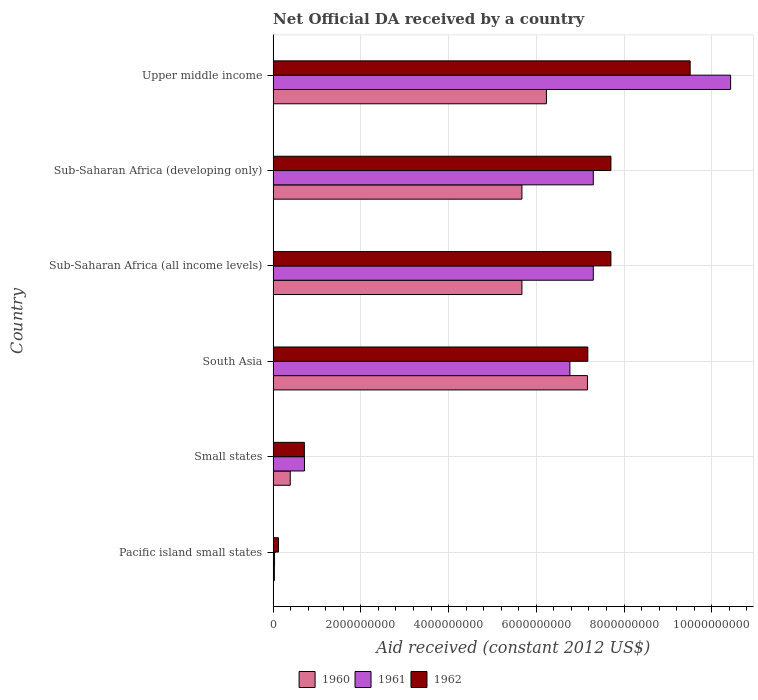How many different coloured bars are there?
Your response must be concise. 3. Are the number of bars on each tick of the Y-axis equal?
Ensure brevity in your answer.  Yes. How many bars are there on the 2nd tick from the top?
Provide a short and direct response. 3. How many bars are there on the 4th tick from the bottom?
Your answer should be compact. 3. What is the label of the 3rd group of bars from the top?
Offer a terse response. Sub-Saharan Africa (all income levels). What is the net official development assistance aid received in 1961 in South Asia?
Your answer should be compact. 6.76e+09. Across all countries, what is the maximum net official development assistance aid received in 1962?
Your answer should be compact. 9.51e+09. Across all countries, what is the minimum net official development assistance aid received in 1961?
Give a very brief answer. 3.25e+07. In which country was the net official development assistance aid received in 1962 maximum?
Provide a succinct answer. Upper middle income. In which country was the net official development assistance aid received in 1960 minimum?
Offer a terse response. Pacific island small states. What is the total net official development assistance aid received in 1960 in the graph?
Your response must be concise. 2.52e+1. What is the difference between the net official development assistance aid received in 1961 in South Asia and that in Upper middle income?
Keep it short and to the point. -3.66e+09. What is the difference between the net official development assistance aid received in 1962 in Upper middle income and the net official development assistance aid received in 1960 in Sub-Saharan Africa (developing only)?
Provide a succinct answer. 3.83e+09. What is the average net official development assistance aid received in 1961 per country?
Keep it short and to the point. 5.42e+09. What is the difference between the net official development assistance aid received in 1961 and net official development assistance aid received in 1960 in South Asia?
Your response must be concise. -4.00e+08. In how many countries, is the net official development assistance aid received in 1961 greater than 2800000000 US$?
Offer a terse response. 4. What is the ratio of the net official development assistance aid received in 1961 in Pacific island small states to that in Small states?
Provide a succinct answer. 0.05. Is the net official development assistance aid received in 1960 in Pacific island small states less than that in Small states?
Provide a short and direct response. Yes. What is the difference between the highest and the second highest net official development assistance aid received in 1960?
Provide a short and direct response. 9.35e+08. What is the difference between the highest and the lowest net official development assistance aid received in 1961?
Ensure brevity in your answer.  1.04e+1. In how many countries, is the net official development assistance aid received in 1962 greater than the average net official development assistance aid received in 1962 taken over all countries?
Your response must be concise. 4. Is the sum of the net official development assistance aid received in 1961 in Pacific island small states and South Asia greater than the maximum net official development assistance aid received in 1962 across all countries?
Offer a terse response. No. What does the 2nd bar from the bottom in Sub-Saharan Africa (all income levels) represents?
Offer a very short reply. 1961. Is it the case that in every country, the sum of the net official development assistance aid received in 1960 and net official development assistance aid received in 1962 is greater than the net official development assistance aid received in 1961?
Provide a succinct answer. Yes. How many bars are there?
Offer a very short reply. 18. How many countries are there in the graph?
Provide a short and direct response. 6. Does the graph contain grids?
Offer a very short reply. Yes. Where does the legend appear in the graph?
Keep it short and to the point. Bottom center. How are the legend labels stacked?
Offer a terse response. Horizontal. What is the title of the graph?
Ensure brevity in your answer.  Net Official DA received by a country. Does "1960" appear as one of the legend labels in the graph?
Your answer should be very brief. Yes. What is the label or title of the X-axis?
Offer a terse response. Aid received (constant 2012 US$). What is the Aid received (constant 2012 US$) in 1960 in Pacific island small states?
Offer a very short reply. 2.87e+07. What is the Aid received (constant 2012 US$) in 1961 in Pacific island small states?
Your answer should be very brief. 3.25e+07. What is the Aid received (constant 2012 US$) in 1962 in Pacific island small states?
Provide a succinct answer. 1.22e+08. What is the Aid received (constant 2012 US$) of 1960 in Small states?
Provide a short and direct response. 3.90e+08. What is the Aid received (constant 2012 US$) of 1961 in Small states?
Make the answer very short. 7.15e+08. What is the Aid received (constant 2012 US$) of 1962 in Small states?
Your response must be concise. 7.12e+08. What is the Aid received (constant 2012 US$) of 1960 in South Asia?
Your answer should be compact. 7.17e+09. What is the Aid received (constant 2012 US$) in 1961 in South Asia?
Your answer should be very brief. 6.76e+09. What is the Aid received (constant 2012 US$) in 1962 in South Asia?
Make the answer very short. 7.17e+09. What is the Aid received (constant 2012 US$) in 1960 in Sub-Saharan Africa (all income levels)?
Offer a very short reply. 5.67e+09. What is the Aid received (constant 2012 US$) in 1961 in Sub-Saharan Africa (all income levels)?
Provide a short and direct response. 7.30e+09. What is the Aid received (constant 2012 US$) of 1962 in Sub-Saharan Africa (all income levels)?
Provide a short and direct response. 7.70e+09. What is the Aid received (constant 2012 US$) in 1960 in Sub-Saharan Africa (developing only)?
Make the answer very short. 5.67e+09. What is the Aid received (constant 2012 US$) of 1961 in Sub-Saharan Africa (developing only)?
Keep it short and to the point. 7.30e+09. What is the Aid received (constant 2012 US$) in 1962 in Sub-Saharan Africa (developing only)?
Your answer should be very brief. 7.70e+09. What is the Aid received (constant 2012 US$) in 1960 in Upper middle income?
Ensure brevity in your answer.  6.23e+09. What is the Aid received (constant 2012 US$) of 1961 in Upper middle income?
Provide a succinct answer. 1.04e+1. What is the Aid received (constant 2012 US$) of 1962 in Upper middle income?
Your answer should be very brief. 9.51e+09. Across all countries, what is the maximum Aid received (constant 2012 US$) of 1960?
Your response must be concise. 7.17e+09. Across all countries, what is the maximum Aid received (constant 2012 US$) in 1961?
Provide a short and direct response. 1.04e+1. Across all countries, what is the maximum Aid received (constant 2012 US$) in 1962?
Provide a succinct answer. 9.51e+09. Across all countries, what is the minimum Aid received (constant 2012 US$) of 1960?
Ensure brevity in your answer.  2.87e+07. Across all countries, what is the minimum Aid received (constant 2012 US$) in 1961?
Make the answer very short. 3.25e+07. Across all countries, what is the minimum Aid received (constant 2012 US$) in 1962?
Provide a succinct answer. 1.22e+08. What is the total Aid received (constant 2012 US$) in 1960 in the graph?
Ensure brevity in your answer.  2.52e+1. What is the total Aid received (constant 2012 US$) of 1961 in the graph?
Provide a succinct answer. 3.25e+1. What is the total Aid received (constant 2012 US$) of 1962 in the graph?
Provide a short and direct response. 3.29e+1. What is the difference between the Aid received (constant 2012 US$) of 1960 in Pacific island small states and that in Small states?
Offer a very short reply. -3.62e+08. What is the difference between the Aid received (constant 2012 US$) of 1961 in Pacific island small states and that in Small states?
Provide a short and direct response. -6.82e+08. What is the difference between the Aid received (constant 2012 US$) of 1962 in Pacific island small states and that in Small states?
Your answer should be very brief. -5.90e+08. What is the difference between the Aid received (constant 2012 US$) in 1960 in Pacific island small states and that in South Asia?
Your response must be concise. -7.14e+09. What is the difference between the Aid received (constant 2012 US$) in 1961 in Pacific island small states and that in South Asia?
Make the answer very short. -6.73e+09. What is the difference between the Aid received (constant 2012 US$) of 1962 in Pacific island small states and that in South Asia?
Provide a succinct answer. -7.05e+09. What is the difference between the Aid received (constant 2012 US$) in 1960 in Pacific island small states and that in Sub-Saharan Africa (all income levels)?
Your response must be concise. -5.64e+09. What is the difference between the Aid received (constant 2012 US$) in 1961 in Pacific island small states and that in Sub-Saharan Africa (all income levels)?
Offer a very short reply. -7.27e+09. What is the difference between the Aid received (constant 2012 US$) in 1962 in Pacific island small states and that in Sub-Saharan Africa (all income levels)?
Your answer should be compact. -7.58e+09. What is the difference between the Aid received (constant 2012 US$) of 1960 in Pacific island small states and that in Sub-Saharan Africa (developing only)?
Offer a very short reply. -5.64e+09. What is the difference between the Aid received (constant 2012 US$) of 1961 in Pacific island small states and that in Sub-Saharan Africa (developing only)?
Provide a short and direct response. -7.27e+09. What is the difference between the Aid received (constant 2012 US$) of 1962 in Pacific island small states and that in Sub-Saharan Africa (developing only)?
Offer a very short reply. -7.58e+09. What is the difference between the Aid received (constant 2012 US$) in 1960 in Pacific island small states and that in Upper middle income?
Your response must be concise. -6.20e+09. What is the difference between the Aid received (constant 2012 US$) of 1961 in Pacific island small states and that in Upper middle income?
Provide a short and direct response. -1.04e+1. What is the difference between the Aid received (constant 2012 US$) in 1962 in Pacific island small states and that in Upper middle income?
Your response must be concise. -9.38e+09. What is the difference between the Aid received (constant 2012 US$) in 1960 in Small states and that in South Asia?
Make the answer very short. -6.77e+09. What is the difference between the Aid received (constant 2012 US$) in 1961 in Small states and that in South Asia?
Offer a terse response. -6.05e+09. What is the difference between the Aid received (constant 2012 US$) in 1962 in Small states and that in South Asia?
Provide a short and direct response. -6.46e+09. What is the difference between the Aid received (constant 2012 US$) in 1960 in Small states and that in Sub-Saharan Africa (all income levels)?
Provide a short and direct response. -5.28e+09. What is the difference between the Aid received (constant 2012 US$) in 1961 in Small states and that in Sub-Saharan Africa (all income levels)?
Keep it short and to the point. -6.58e+09. What is the difference between the Aid received (constant 2012 US$) in 1962 in Small states and that in Sub-Saharan Africa (all income levels)?
Your response must be concise. -6.99e+09. What is the difference between the Aid received (constant 2012 US$) of 1960 in Small states and that in Sub-Saharan Africa (developing only)?
Provide a succinct answer. -5.28e+09. What is the difference between the Aid received (constant 2012 US$) of 1961 in Small states and that in Sub-Saharan Africa (developing only)?
Keep it short and to the point. -6.58e+09. What is the difference between the Aid received (constant 2012 US$) in 1962 in Small states and that in Sub-Saharan Africa (developing only)?
Keep it short and to the point. -6.99e+09. What is the difference between the Aid received (constant 2012 US$) of 1960 in Small states and that in Upper middle income?
Offer a terse response. -5.84e+09. What is the difference between the Aid received (constant 2012 US$) in 1961 in Small states and that in Upper middle income?
Give a very brief answer. -9.71e+09. What is the difference between the Aid received (constant 2012 US$) in 1962 in Small states and that in Upper middle income?
Give a very brief answer. -8.79e+09. What is the difference between the Aid received (constant 2012 US$) of 1960 in South Asia and that in Sub-Saharan Africa (all income levels)?
Provide a succinct answer. 1.49e+09. What is the difference between the Aid received (constant 2012 US$) of 1961 in South Asia and that in Sub-Saharan Africa (all income levels)?
Your answer should be compact. -5.34e+08. What is the difference between the Aid received (constant 2012 US$) of 1962 in South Asia and that in Sub-Saharan Africa (all income levels)?
Give a very brief answer. -5.27e+08. What is the difference between the Aid received (constant 2012 US$) in 1960 in South Asia and that in Sub-Saharan Africa (developing only)?
Make the answer very short. 1.49e+09. What is the difference between the Aid received (constant 2012 US$) in 1961 in South Asia and that in Sub-Saharan Africa (developing only)?
Give a very brief answer. -5.34e+08. What is the difference between the Aid received (constant 2012 US$) of 1962 in South Asia and that in Sub-Saharan Africa (developing only)?
Offer a terse response. -5.27e+08. What is the difference between the Aid received (constant 2012 US$) in 1960 in South Asia and that in Upper middle income?
Your answer should be very brief. 9.35e+08. What is the difference between the Aid received (constant 2012 US$) in 1961 in South Asia and that in Upper middle income?
Offer a very short reply. -3.66e+09. What is the difference between the Aid received (constant 2012 US$) in 1962 in South Asia and that in Upper middle income?
Provide a succinct answer. -2.33e+09. What is the difference between the Aid received (constant 2012 US$) in 1961 in Sub-Saharan Africa (all income levels) and that in Sub-Saharan Africa (developing only)?
Provide a short and direct response. 0. What is the difference between the Aid received (constant 2012 US$) of 1960 in Sub-Saharan Africa (all income levels) and that in Upper middle income?
Your answer should be very brief. -5.58e+08. What is the difference between the Aid received (constant 2012 US$) in 1961 in Sub-Saharan Africa (all income levels) and that in Upper middle income?
Make the answer very short. -3.13e+09. What is the difference between the Aid received (constant 2012 US$) of 1962 in Sub-Saharan Africa (all income levels) and that in Upper middle income?
Provide a short and direct response. -1.81e+09. What is the difference between the Aid received (constant 2012 US$) of 1960 in Sub-Saharan Africa (developing only) and that in Upper middle income?
Keep it short and to the point. -5.58e+08. What is the difference between the Aid received (constant 2012 US$) of 1961 in Sub-Saharan Africa (developing only) and that in Upper middle income?
Ensure brevity in your answer.  -3.13e+09. What is the difference between the Aid received (constant 2012 US$) of 1962 in Sub-Saharan Africa (developing only) and that in Upper middle income?
Your response must be concise. -1.81e+09. What is the difference between the Aid received (constant 2012 US$) in 1960 in Pacific island small states and the Aid received (constant 2012 US$) in 1961 in Small states?
Make the answer very short. -6.86e+08. What is the difference between the Aid received (constant 2012 US$) of 1960 in Pacific island small states and the Aid received (constant 2012 US$) of 1962 in Small states?
Give a very brief answer. -6.83e+08. What is the difference between the Aid received (constant 2012 US$) of 1961 in Pacific island small states and the Aid received (constant 2012 US$) of 1962 in Small states?
Offer a very short reply. -6.80e+08. What is the difference between the Aid received (constant 2012 US$) in 1960 in Pacific island small states and the Aid received (constant 2012 US$) in 1961 in South Asia?
Keep it short and to the point. -6.74e+09. What is the difference between the Aid received (constant 2012 US$) of 1960 in Pacific island small states and the Aid received (constant 2012 US$) of 1962 in South Asia?
Your response must be concise. -7.14e+09. What is the difference between the Aid received (constant 2012 US$) in 1961 in Pacific island small states and the Aid received (constant 2012 US$) in 1962 in South Asia?
Offer a terse response. -7.14e+09. What is the difference between the Aid received (constant 2012 US$) in 1960 in Pacific island small states and the Aid received (constant 2012 US$) in 1961 in Sub-Saharan Africa (all income levels)?
Offer a very short reply. -7.27e+09. What is the difference between the Aid received (constant 2012 US$) in 1960 in Pacific island small states and the Aid received (constant 2012 US$) in 1962 in Sub-Saharan Africa (all income levels)?
Your response must be concise. -7.67e+09. What is the difference between the Aid received (constant 2012 US$) of 1961 in Pacific island small states and the Aid received (constant 2012 US$) of 1962 in Sub-Saharan Africa (all income levels)?
Offer a terse response. -7.67e+09. What is the difference between the Aid received (constant 2012 US$) of 1960 in Pacific island small states and the Aid received (constant 2012 US$) of 1961 in Sub-Saharan Africa (developing only)?
Make the answer very short. -7.27e+09. What is the difference between the Aid received (constant 2012 US$) in 1960 in Pacific island small states and the Aid received (constant 2012 US$) in 1962 in Sub-Saharan Africa (developing only)?
Your answer should be very brief. -7.67e+09. What is the difference between the Aid received (constant 2012 US$) in 1961 in Pacific island small states and the Aid received (constant 2012 US$) in 1962 in Sub-Saharan Africa (developing only)?
Give a very brief answer. -7.67e+09. What is the difference between the Aid received (constant 2012 US$) in 1960 in Pacific island small states and the Aid received (constant 2012 US$) in 1961 in Upper middle income?
Keep it short and to the point. -1.04e+1. What is the difference between the Aid received (constant 2012 US$) of 1960 in Pacific island small states and the Aid received (constant 2012 US$) of 1962 in Upper middle income?
Offer a terse response. -9.48e+09. What is the difference between the Aid received (constant 2012 US$) in 1961 in Pacific island small states and the Aid received (constant 2012 US$) in 1962 in Upper middle income?
Offer a terse response. -9.47e+09. What is the difference between the Aid received (constant 2012 US$) of 1960 in Small states and the Aid received (constant 2012 US$) of 1961 in South Asia?
Provide a short and direct response. -6.37e+09. What is the difference between the Aid received (constant 2012 US$) of 1960 in Small states and the Aid received (constant 2012 US$) of 1962 in South Asia?
Your answer should be very brief. -6.78e+09. What is the difference between the Aid received (constant 2012 US$) of 1961 in Small states and the Aid received (constant 2012 US$) of 1962 in South Asia?
Your response must be concise. -6.46e+09. What is the difference between the Aid received (constant 2012 US$) of 1960 in Small states and the Aid received (constant 2012 US$) of 1961 in Sub-Saharan Africa (all income levels)?
Provide a short and direct response. -6.91e+09. What is the difference between the Aid received (constant 2012 US$) of 1960 in Small states and the Aid received (constant 2012 US$) of 1962 in Sub-Saharan Africa (all income levels)?
Offer a very short reply. -7.31e+09. What is the difference between the Aid received (constant 2012 US$) of 1961 in Small states and the Aid received (constant 2012 US$) of 1962 in Sub-Saharan Africa (all income levels)?
Your answer should be compact. -6.99e+09. What is the difference between the Aid received (constant 2012 US$) in 1960 in Small states and the Aid received (constant 2012 US$) in 1961 in Sub-Saharan Africa (developing only)?
Offer a very short reply. -6.91e+09. What is the difference between the Aid received (constant 2012 US$) in 1960 in Small states and the Aid received (constant 2012 US$) in 1962 in Sub-Saharan Africa (developing only)?
Your response must be concise. -7.31e+09. What is the difference between the Aid received (constant 2012 US$) of 1961 in Small states and the Aid received (constant 2012 US$) of 1962 in Sub-Saharan Africa (developing only)?
Make the answer very short. -6.99e+09. What is the difference between the Aid received (constant 2012 US$) in 1960 in Small states and the Aid received (constant 2012 US$) in 1961 in Upper middle income?
Your answer should be very brief. -1.00e+1. What is the difference between the Aid received (constant 2012 US$) in 1960 in Small states and the Aid received (constant 2012 US$) in 1962 in Upper middle income?
Your answer should be very brief. -9.12e+09. What is the difference between the Aid received (constant 2012 US$) of 1961 in Small states and the Aid received (constant 2012 US$) of 1962 in Upper middle income?
Offer a very short reply. -8.79e+09. What is the difference between the Aid received (constant 2012 US$) of 1960 in South Asia and the Aid received (constant 2012 US$) of 1961 in Sub-Saharan Africa (all income levels)?
Offer a very short reply. -1.33e+08. What is the difference between the Aid received (constant 2012 US$) of 1960 in South Asia and the Aid received (constant 2012 US$) of 1962 in Sub-Saharan Africa (all income levels)?
Offer a terse response. -5.35e+08. What is the difference between the Aid received (constant 2012 US$) in 1961 in South Asia and the Aid received (constant 2012 US$) in 1962 in Sub-Saharan Africa (all income levels)?
Your answer should be compact. -9.35e+08. What is the difference between the Aid received (constant 2012 US$) of 1960 in South Asia and the Aid received (constant 2012 US$) of 1961 in Sub-Saharan Africa (developing only)?
Ensure brevity in your answer.  -1.33e+08. What is the difference between the Aid received (constant 2012 US$) in 1960 in South Asia and the Aid received (constant 2012 US$) in 1962 in Sub-Saharan Africa (developing only)?
Make the answer very short. -5.35e+08. What is the difference between the Aid received (constant 2012 US$) of 1961 in South Asia and the Aid received (constant 2012 US$) of 1962 in Sub-Saharan Africa (developing only)?
Your answer should be very brief. -9.35e+08. What is the difference between the Aid received (constant 2012 US$) of 1960 in South Asia and the Aid received (constant 2012 US$) of 1961 in Upper middle income?
Make the answer very short. -3.26e+09. What is the difference between the Aid received (constant 2012 US$) of 1960 in South Asia and the Aid received (constant 2012 US$) of 1962 in Upper middle income?
Make the answer very short. -2.34e+09. What is the difference between the Aid received (constant 2012 US$) of 1961 in South Asia and the Aid received (constant 2012 US$) of 1962 in Upper middle income?
Give a very brief answer. -2.74e+09. What is the difference between the Aid received (constant 2012 US$) of 1960 in Sub-Saharan Africa (all income levels) and the Aid received (constant 2012 US$) of 1961 in Sub-Saharan Africa (developing only)?
Provide a short and direct response. -1.63e+09. What is the difference between the Aid received (constant 2012 US$) in 1960 in Sub-Saharan Africa (all income levels) and the Aid received (constant 2012 US$) in 1962 in Sub-Saharan Africa (developing only)?
Make the answer very short. -2.03e+09. What is the difference between the Aid received (constant 2012 US$) in 1961 in Sub-Saharan Africa (all income levels) and the Aid received (constant 2012 US$) in 1962 in Sub-Saharan Africa (developing only)?
Keep it short and to the point. -4.02e+08. What is the difference between the Aid received (constant 2012 US$) in 1960 in Sub-Saharan Africa (all income levels) and the Aid received (constant 2012 US$) in 1961 in Upper middle income?
Provide a succinct answer. -4.76e+09. What is the difference between the Aid received (constant 2012 US$) of 1960 in Sub-Saharan Africa (all income levels) and the Aid received (constant 2012 US$) of 1962 in Upper middle income?
Your response must be concise. -3.83e+09. What is the difference between the Aid received (constant 2012 US$) of 1961 in Sub-Saharan Africa (all income levels) and the Aid received (constant 2012 US$) of 1962 in Upper middle income?
Provide a succinct answer. -2.21e+09. What is the difference between the Aid received (constant 2012 US$) in 1960 in Sub-Saharan Africa (developing only) and the Aid received (constant 2012 US$) in 1961 in Upper middle income?
Your response must be concise. -4.76e+09. What is the difference between the Aid received (constant 2012 US$) of 1960 in Sub-Saharan Africa (developing only) and the Aid received (constant 2012 US$) of 1962 in Upper middle income?
Ensure brevity in your answer.  -3.83e+09. What is the difference between the Aid received (constant 2012 US$) in 1961 in Sub-Saharan Africa (developing only) and the Aid received (constant 2012 US$) in 1962 in Upper middle income?
Your answer should be compact. -2.21e+09. What is the average Aid received (constant 2012 US$) of 1960 per country?
Your answer should be very brief. 4.19e+09. What is the average Aid received (constant 2012 US$) in 1961 per country?
Your answer should be compact. 5.42e+09. What is the average Aid received (constant 2012 US$) of 1962 per country?
Ensure brevity in your answer.  5.49e+09. What is the difference between the Aid received (constant 2012 US$) of 1960 and Aid received (constant 2012 US$) of 1961 in Pacific island small states?
Keep it short and to the point. -3.76e+06. What is the difference between the Aid received (constant 2012 US$) of 1960 and Aid received (constant 2012 US$) of 1962 in Pacific island small states?
Keep it short and to the point. -9.36e+07. What is the difference between the Aid received (constant 2012 US$) of 1961 and Aid received (constant 2012 US$) of 1962 in Pacific island small states?
Make the answer very short. -8.98e+07. What is the difference between the Aid received (constant 2012 US$) in 1960 and Aid received (constant 2012 US$) in 1961 in Small states?
Your response must be concise. -3.24e+08. What is the difference between the Aid received (constant 2012 US$) of 1960 and Aid received (constant 2012 US$) of 1962 in Small states?
Offer a very short reply. -3.22e+08. What is the difference between the Aid received (constant 2012 US$) in 1961 and Aid received (constant 2012 US$) in 1962 in Small states?
Make the answer very short. 2.71e+06. What is the difference between the Aid received (constant 2012 US$) of 1960 and Aid received (constant 2012 US$) of 1961 in South Asia?
Offer a very short reply. 4.00e+08. What is the difference between the Aid received (constant 2012 US$) in 1960 and Aid received (constant 2012 US$) in 1962 in South Asia?
Your answer should be compact. -8.03e+06. What is the difference between the Aid received (constant 2012 US$) in 1961 and Aid received (constant 2012 US$) in 1962 in South Asia?
Make the answer very short. -4.08e+08. What is the difference between the Aid received (constant 2012 US$) of 1960 and Aid received (constant 2012 US$) of 1961 in Sub-Saharan Africa (all income levels)?
Ensure brevity in your answer.  -1.63e+09. What is the difference between the Aid received (constant 2012 US$) in 1960 and Aid received (constant 2012 US$) in 1962 in Sub-Saharan Africa (all income levels)?
Keep it short and to the point. -2.03e+09. What is the difference between the Aid received (constant 2012 US$) of 1961 and Aid received (constant 2012 US$) of 1962 in Sub-Saharan Africa (all income levels)?
Give a very brief answer. -4.02e+08. What is the difference between the Aid received (constant 2012 US$) in 1960 and Aid received (constant 2012 US$) in 1961 in Sub-Saharan Africa (developing only)?
Make the answer very short. -1.63e+09. What is the difference between the Aid received (constant 2012 US$) in 1960 and Aid received (constant 2012 US$) in 1962 in Sub-Saharan Africa (developing only)?
Keep it short and to the point. -2.03e+09. What is the difference between the Aid received (constant 2012 US$) of 1961 and Aid received (constant 2012 US$) of 1962 in Sub-Saharan Africa (developing only)?
Ensure brevity in your answer.  -4.02e+08. What is the difference between the Aid received (constant 2012 US$) in 1960 and Aid received (constant 2012 US$) in 1961 in Upper middle income?
Your response must be concise. -4.20e+09. What is the difference between the Aid received (constant 2012 US$) of 1960 and Aid received (constant 2012 US$) of 1962 in Upper middle income?
Provide a short and direct response. -3.28e+09. What is the difference between the Aid received (constant 2012 US$) of 1961 and Aid received (constant 2012 US$) of 1962 in Upper middle income?
Ensure brevity in your answer.  9.22e+08. What is the ratio of the Aid received (constant 2012 US$) of 1960 in Pacific island small states to that in Small states?
Ensure brevity in your answer.  0.07. What is the ratio of the Aid received (constant 2012 US$) in 1961 in Pacific island small states to that in Small states?
Provide a succinct answer. 0.05. What is the ratio of the Aid received (constant 2012 US$) in 1962 in Pacific island small states to that in Small states?
Provide a succinct answer. 0.17. What is the ratio of the Aid received (constant 2012 US$) in 1960 in Pacific island small states to that in South Asia?
Give a very brief answer. 0. What is the ratio of the Aid received (constant 2012 US$) in 1961 in Pacific island small states to that in South Asia?
Ensure brevity in your answer.  0. What is the ratio of the Aid received (constant 2012 US$) of 1962 in Pacific island small states to that in South Asia?
Your answer should be very brief. 0.02. What is the ratio of the Aid received (constant 2012 US$) of 1960 in Pacific island small states to that in Sub-Saharan Africa (all income levels)?
Ensure brevity in your answer.  0.01. What is the ratio of the Aid received (constant 2012 US$) of 1961 in Pacific island small states to that in Sub-Saharan Africa (all income levels)?
Your answer should be very brief. 0. What is the ratio of the Aid received (constant 2012 US$) of 1962 in Pacific island small states to that in Sub-Saharan Africa (all income levels)?
Keep it short and to the point. 0.02. What is the ratio of the Aid received (constant 2012 US$) of 1960 in Pacific island small states to that in Sub-Saharan Africa (developing only)?
Offer a terse response. 0.01. What is the ratio of the Aid received (constant 2012 US$) in 1961 in Pacific island small states to that in Sub-Saharan Africa (developing only)?
Your response must be concise. 0. What is the ratio of the Aid received (constant 2012 US$) in 1962 in Pacific island small states to that in Sub-Saharan Africa (developing only)?
Ensure brevity in your answer.  0.02. What is the ratio of the Aid received (constant 2012 US$) in 1960 in Pacific island small states to that in Upper middle income?
Give a very brief answer. 0. What is the ratio of the Aid received (constant 2012 US$) of 1961 in Pacific island small states to that in Upper middle income?
Provide a succinct answer. 0. What is the ratio of the Aid received (constant 2012 US$) in 1962 in Pacific island small states to that in Upper middle income?
Offer a terse response. 0.01. What is the ratio of the Aid received (constant 2012 US$) of 1960 in Small states to that in South Asia?
Make the answer very short. 0.05. What is the ratio of the Aid received (constant 2012 US$) of 1961 in Small states to that in South Asia?
Ensure brevity in your answer.  0.11. What is the ratio of the Aid received (constant 2012 US$) of 1962 in Small states to that in South Asia?
Offer a very short reply. 0.1. What is the ratio of the Aid received (constant 2012 US$) of 1960 in Small states to that in Sub-Saharan Africa (all income levels)?
Keep it short and to the point. 0.07. What is the ratio of the Aid received (constant 2012 US$) of 1961 in Small states to that in Sub-Saharan Africa (all income levels)?
Ensure brevity in your answer.  0.1. What is the ratio of the Aid received (constant 2012 US$) of 1962 in Small states to that in Sub-Saharan Africa (all income levels)?
Offer a very short reply. 0.09. What is the ratio of the Aid received (constant 2012 US$) of 1960 in Small states to that in Sub-Saharan Africa (developing only)?
Keep it short and to the point. 0.07. What is the ratio of the Aid received (constant 2012 US$) of 1961 in Small states to that in Sub-Saharan Africa (developing only)?
Offer a very short reply. 0.1. What is the ratio of the Aid received (constant 2012 US$) of 1962 in Small states to that in Sub-Saharan Africa (developing only)?
Offer a terse response. 0.09. What is the ratio of the Aid received (constant 2012 US$) in 1960 in Small states to that in Upper middle income?
Provide a succinct answer. 0.06. What is the ratio of the Aid received (constant 2012 US$) in 1961 in Small states to that in Upper middle income?
Offer a terse response. 0.07. What is the ratio of the Aid received (constant 2012 US$) of 1962 in Small states to that in Upper middle income?
Your response must be concise. 0.07. What is the ratio of the Aid received (constant 2012 US$) in 1960 in South Asia to that in Sub-Saharan Africa (all income levels)?
Provide a succinct answer. 1.26. What is the ratio of the Aid received (constant 2012 US$) of 1961 in South Asia to that in Sub-Saharan Africa (all income levels)?
Your answer should be very brief. 0.93. What is the ratio of the Aid received (constant 2012 US$) of 1962 in South Asia to that in Sub-Saharan Africa (all income levels)?
Provide a succinct answer. 0.93. What is the ratio of the Aid received (constant 2012 US$) of 1960 in South Asia to that in Sub-Saharan Africa (developing only)?
Make the answer very short. 1.26. What is the ratio of the Aid received (constant 2012 US$) of 1961 in South Asia to that in Sub-Saharan Africa (developing only)?
Offer a very short reply. 0.93. What is the ratio of the Aid received (constant 2012 US$) of 1962 in South Asia to that in Sub-Saharan Africa (developing only)?
Give a very brief answer. 0.93. What is the ratio of the Aid received (constant 2012 US$) in 1960 in South Asia to that in Upper middle income?
Provide a short and direct response. 1.15. What is the ratio of the Aid received (constant 2012 US$) of 1961 in South Asia to that in Upper middle income?
Offer a very short reply. 0.65. What is the ratio of the Aid received (constant 2012 US$) of 1962 in South Asia to that in Upper middle income?
Offer a terse response. 0.75. What is the ratio of the Aid received (constant 2012 US$) of 1961 in Sub-Saharan Africa (all income levels) to that in Sub-Saharan Africa (developing only)?
Offer a very short reply. 1. What is the ratio of the Aid received (constant 2012 US$) in 1960 in Sub-Saharan Africa (all income levels) to that in Upper middle income?
Keep it short and to the point. 0.91. What is the ratio of the Aid received (constant 2012 US$) in 1961 in Sub-Saharan Africa (all income levels) to that in Upper middle income?
Offer a terse response. 0.7. What is the ratio of the Aid received (constant 2012 US$) in 1962 in Sub-Saharan Africa (all income levels) to that in Upper middle income?
Your answer should be compact. 0.81. What is the ratio of the Aid received (constant 2012 US$) in 1960 in Sub-Saharan Africa (developing only) to that in Upper middle income?
Ensure brevity in your answer.  0.91. What is the ratio of the Aid received (constant 2012 US$) of 1961 in Sub-Saharan Africa (developing only) to that in Upper middle income?
Your answer should be compact. 0.7. What is the ratio of the Aid received (constant 2012 US$) of 1962 in Sub-Saharan Africa (developing only) to that in Upper middle income?
Provide a succinct answer. 0.81. What is the difference between the highest and the second highest Aid received (constant 2012 US$) in 1960?
Provide a short and direct response. 9.35e+08. What is the difference between the highest and the second highest Aid received (constant 2012 US$) in 1961?
Make the answer very short. 3.13e+09. What is the difference between the highest and the second highest Aid received (constant 2012 US$) of 1962?
Make the answer very short. 1.81e+09. What is the difference between the highest and the lowest Aid received (constant 2012 US$) in 1960?
Your response must be concise. 7.14e+09. What is the difference between the highest and the lowest Aid received (constant 2012 US$) in 1961?
Offer a terse response. 1.04e+1. What is the difference between the highest and the lowest Aid received (constant 2012 US$) in 1962?
Provide a succinct answer. 9.38e+09. 